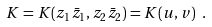<formula> <loc_0><loc_0><loc_500><loc_500>K = K ( z _ { 1 } { \bar { z } } _ { 1 } , z _ { 2 } { \bar { z } } _ { 2 } ) = K ( u , v ) \ .</formula> 